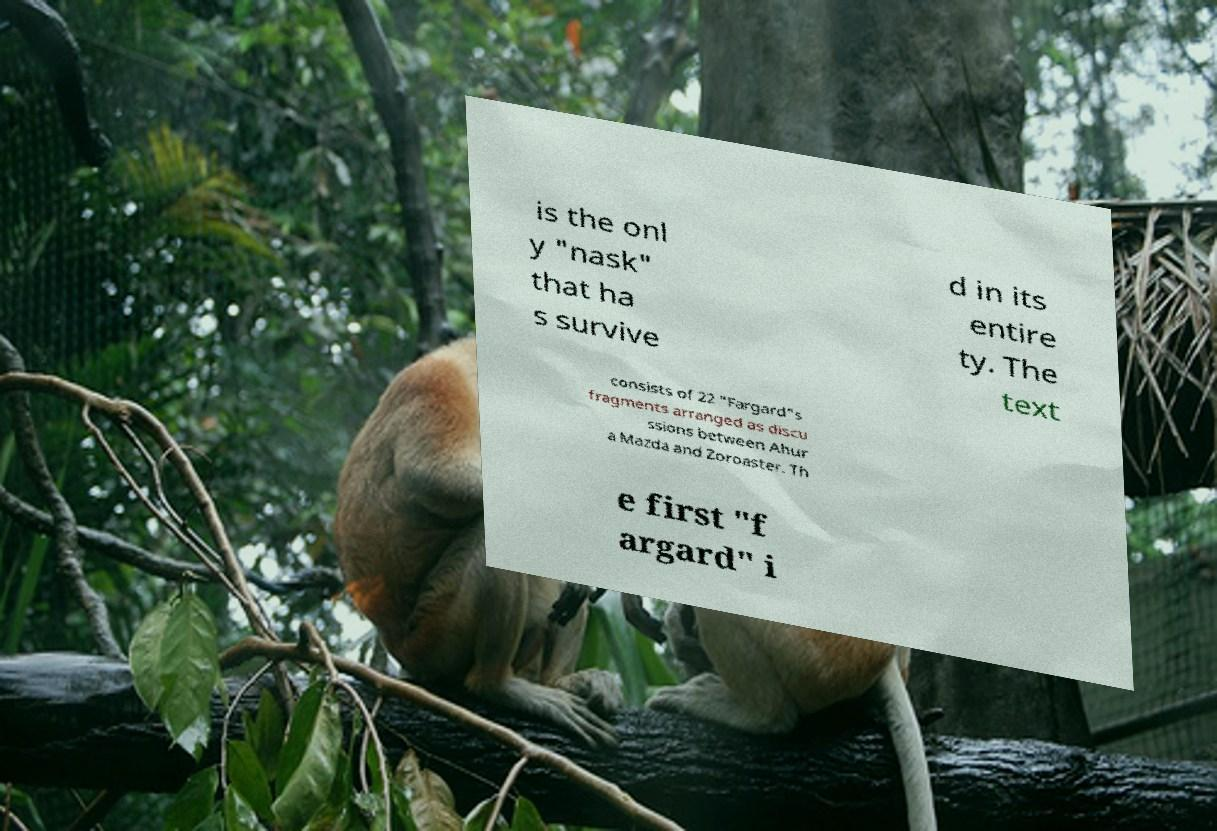For documentation purposes, I need the text within this image transcribed. Could you provide that? is the onl y "nask" that ha s survive d in its entire ty. The text consists of 22 "Fargard"s fragments arranged as discu ssions between Ahur a Mazda and Zoroaster. Th e first "f argard" i 